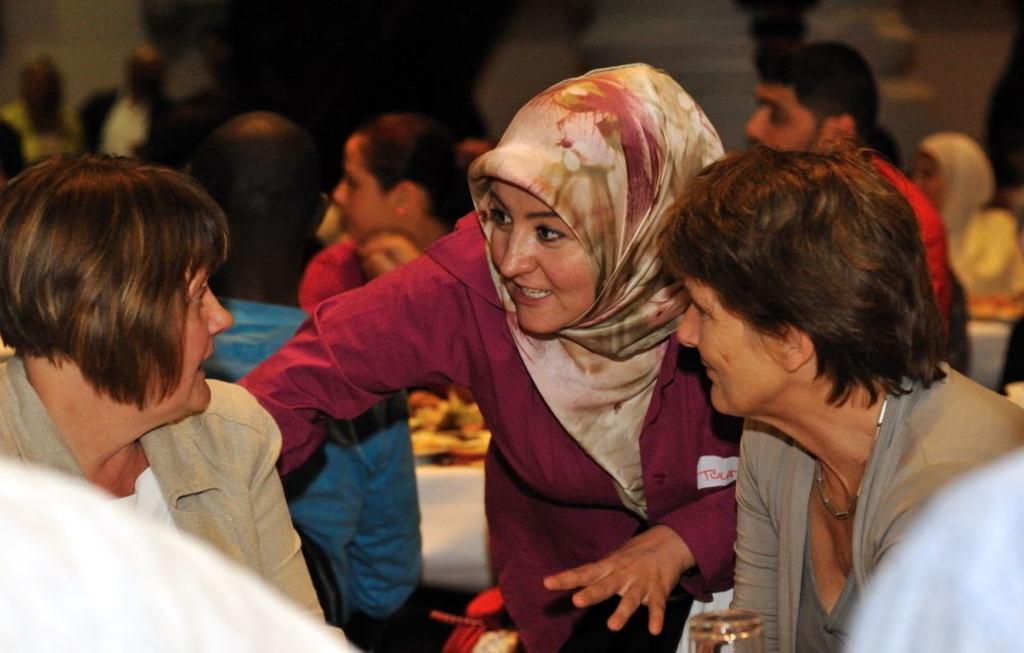In one or two sentences, can you explain what this image depicts? There are people. In the background we can see people and it is dark. 